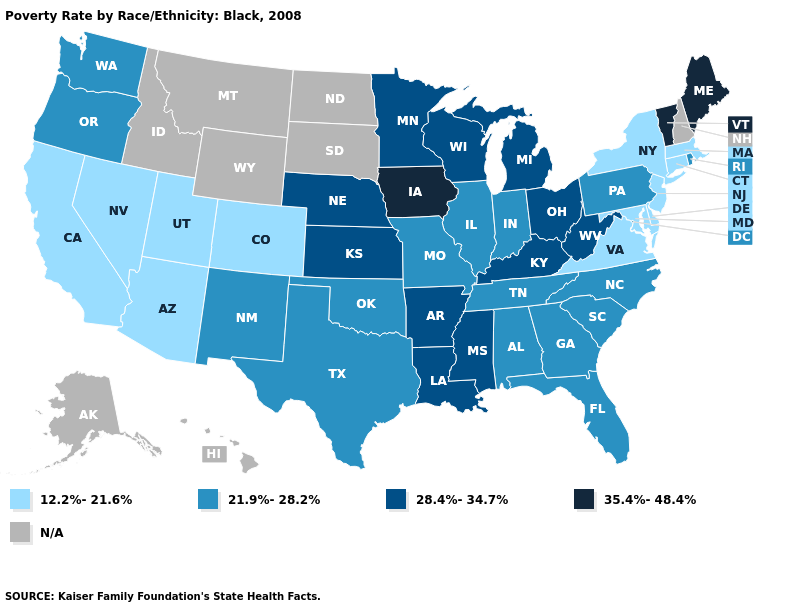What is the value of Missouri?
Quick response, please. 21.9%-28.2%. Does the map have missing data?
Write a very short answer. Yes. What is the value of Texas?
Write a very short answer. 21.9%-28.2%. How many symbols are there in the legend?
Write a very short answer. 5. How many symbols are there in the legend?
Keep it brief. 5. Does California have the lowest value in the West?
Keep it brief. Yes. What is the highest value in the South ?
Concise answer only. 28.4%-34.7%. Is the legend a continuous bar?
Quick response, please. No. What is the highest value in the USA?
Concise answer only. 35.4%-48.4%. Among the states that border Washington , which have the lowest value?
Give a very brief answer. Oregon. What is the value of Wyoming?
Quick response, please. N/A. What is the value of Michigan?
Be succinct. 28.4%-34.7%. What is the value of Maryland?
Keep it brief. 12.2%-21.6%. What is the value of Connecticut?
Answer briefly. 12.2%-21.6%. 